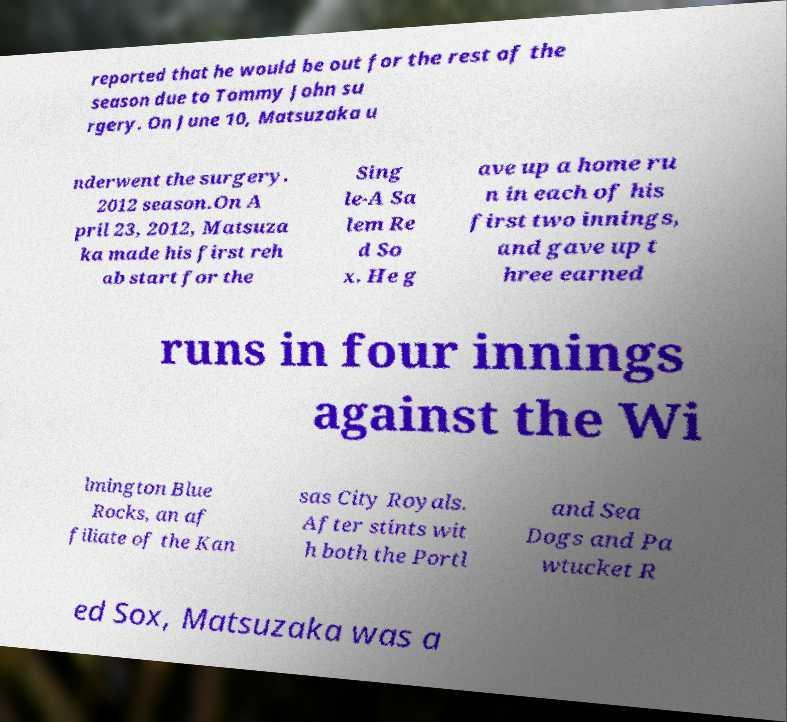Can you accurately transcribe the text from the provided image for me? reported that he would be out for the rest of the season due to Tommy John su rgery. On June 10, Matsuzaka u nderwent the surgery. 2012 season.On A pril 23, 2012, Matsuza ka made his first reh ab start for the Sing le-A Sa lem Re d So x. He g ave up a home ru n in each of his first two innings, and gave up t hree earned runs in four innings against the Wi lmington Blue Rocks, an af filiate of the Kan sas City Royals. After stints wit h both the Portl and Sea Dogs and Pa wtucket R ed Sox, Matsuzaka was a 